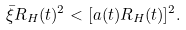Convert formula to latex. <formula><loc_0><loc_0><loc_500><loc_500>\bar { \xi } R _ { H } ( t ) ^ { 2 } < [ a ( t ) R _ { H } ( t ) ] ^ { 2 } .</formula> 